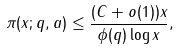<formula> <loc_0><loc_0><loc_500><loc_500>\pi ( x ; q , a ) \leq \frac { ( C + o ( 1 ) ) x } { \phi ( q ) \log { x } } ,</formula> 